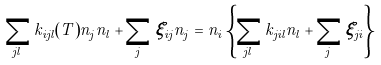Convert formula to latex. <formula><loc_0><loc_0><loc_500><loc_500>\sum _ { j l } k _ { i j l } ( T ) n _ { j } n _ { l } + \sum _ { j } \xi _ { i j } n _ { j } = n _ { i } \left \{ \sum _ { j l } k _ { j i l } n _ { l } + \sum _ { j } \xi _ { j i } \right \}</formula> 